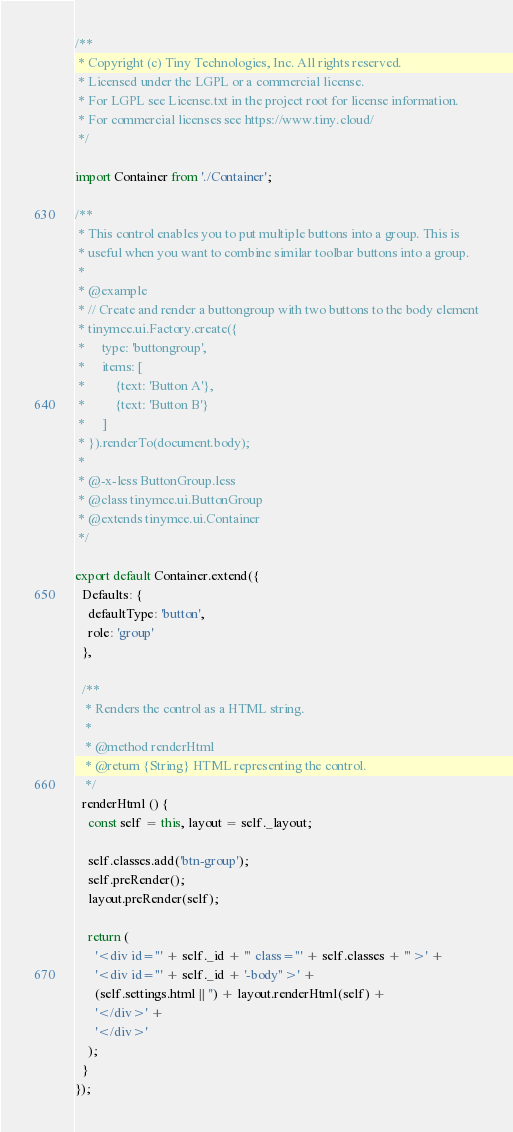<code> <loc_0><loc_0><loc_500><loc_500><_TypeScript_>/**
 * Copyright (c) Tiny Technologies, Inc. All rights reserved.
 * Licensed under the LGPL or a commercial license.
 * For LGPL see License.txt in the project root for license information.
 * For commercial licenses see https://www.tiny.cloud/
 */

import Container from './Container';

/**
 * This control enables you to put multiple buttons into a group. This is
 * useful when you want to combine similar toolbar buttons into a group.
 *
 * @example
 * // Create and render a buttongroup with two buttons to the body element
 * tinymce.ui.Factory.create({
 *     type: 'buttongroup',
 *     items: [
 *         {text: 'Button A'},
 *         {text: 'Button B'}
 *     ]
 * }).renderTo(document.body);
 *
 * @-x-less ButtonGroup.less
 * @class tinymce.ui.ButtonGroup
 * @extends tinymce.ui.Container
 */

export default Container.extend({
  Defaults: {
    defaultType: 'button',
    role: 'group'
  },

  /**
   * Renders the control as a HTML string.
   *
   * @method renderHtml
   * @return {String} HTML representing the control.
   */
  renderHtml () {
    const self = this, layout = self._layout;

    self.classes.add('btn-group');
    self.preRender();
    layout.preRender(self);

    return (
      '<div id="' + self._id + '" class="' + self.classes + '">' +
      '<div id="' + self._id + '-body">' +
      (self.settings.html || '') + layout.renderHtml(self) +
      '</div>' +
      '</div>'
    );
  }
});</code> 